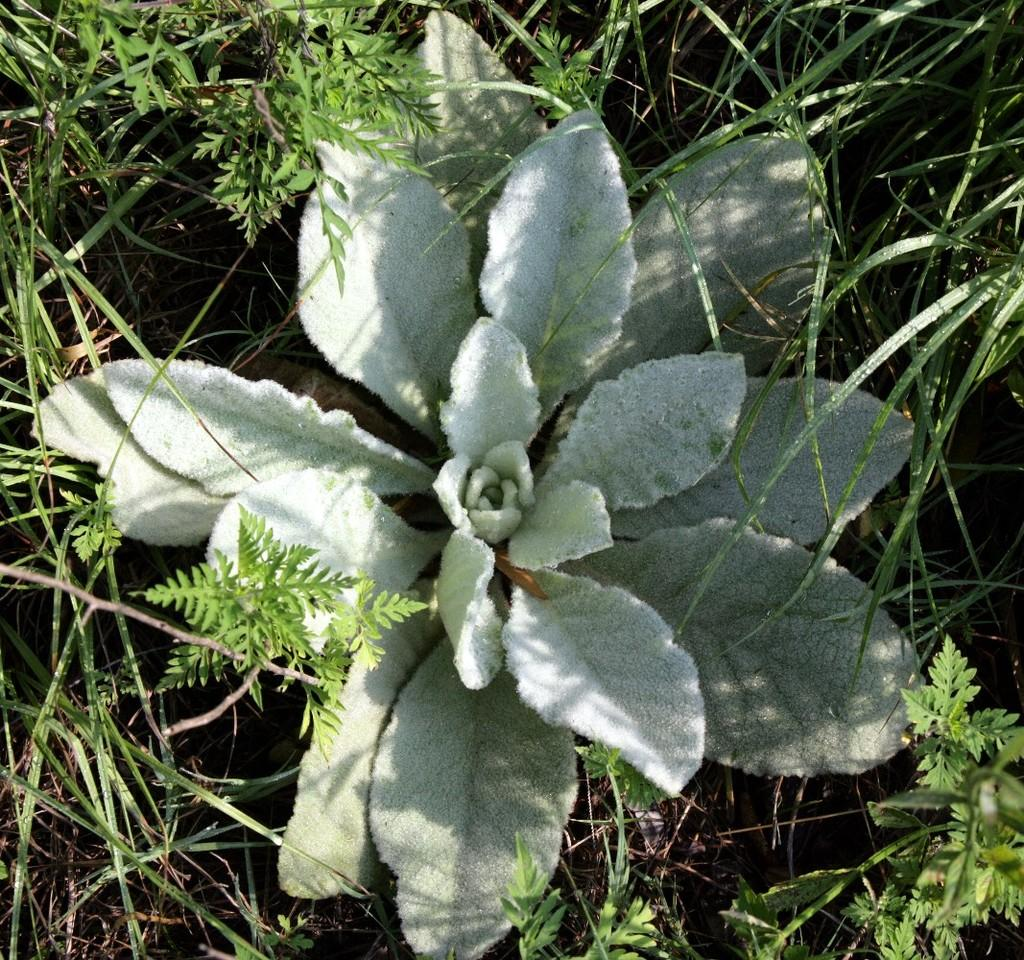What type of vegetation can be seen in the image? There are many plants in the image. What type of ground cover is visible in the image? There is grass visible in the image. Where is the hydrant located in the image? There is no hydrant present in the image. What type of cable can be seen connecting the plants in the image? There is no cable connecting the plants in the image; the plants are not connected by any visible cables. 